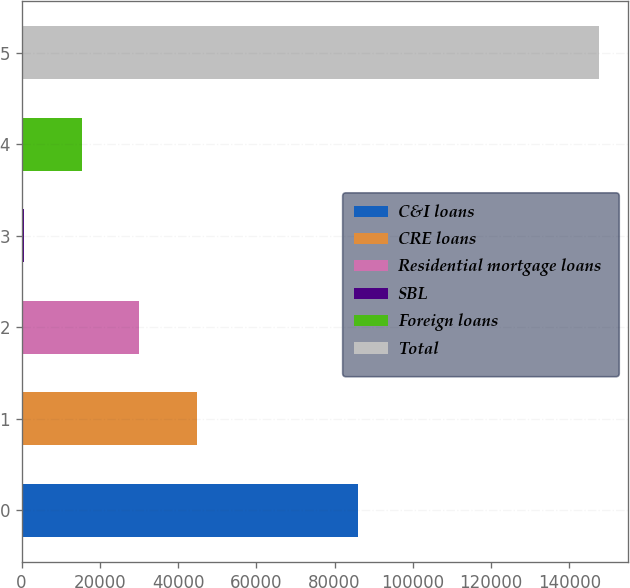<chart> <loc_0><loc_0><loc_500><loc_500><bar_chart><fcel>C&I loans<fcel>CRE loans<fcel>Residential mortgage loans<fcel>SBL<fcel>Foreign loans<fcel>Total<nl><fcel>85916<fcel>44755.8<fcel>30072.2<fcel>705<fcel>15388.6<fcel>147541<nl></chart> 